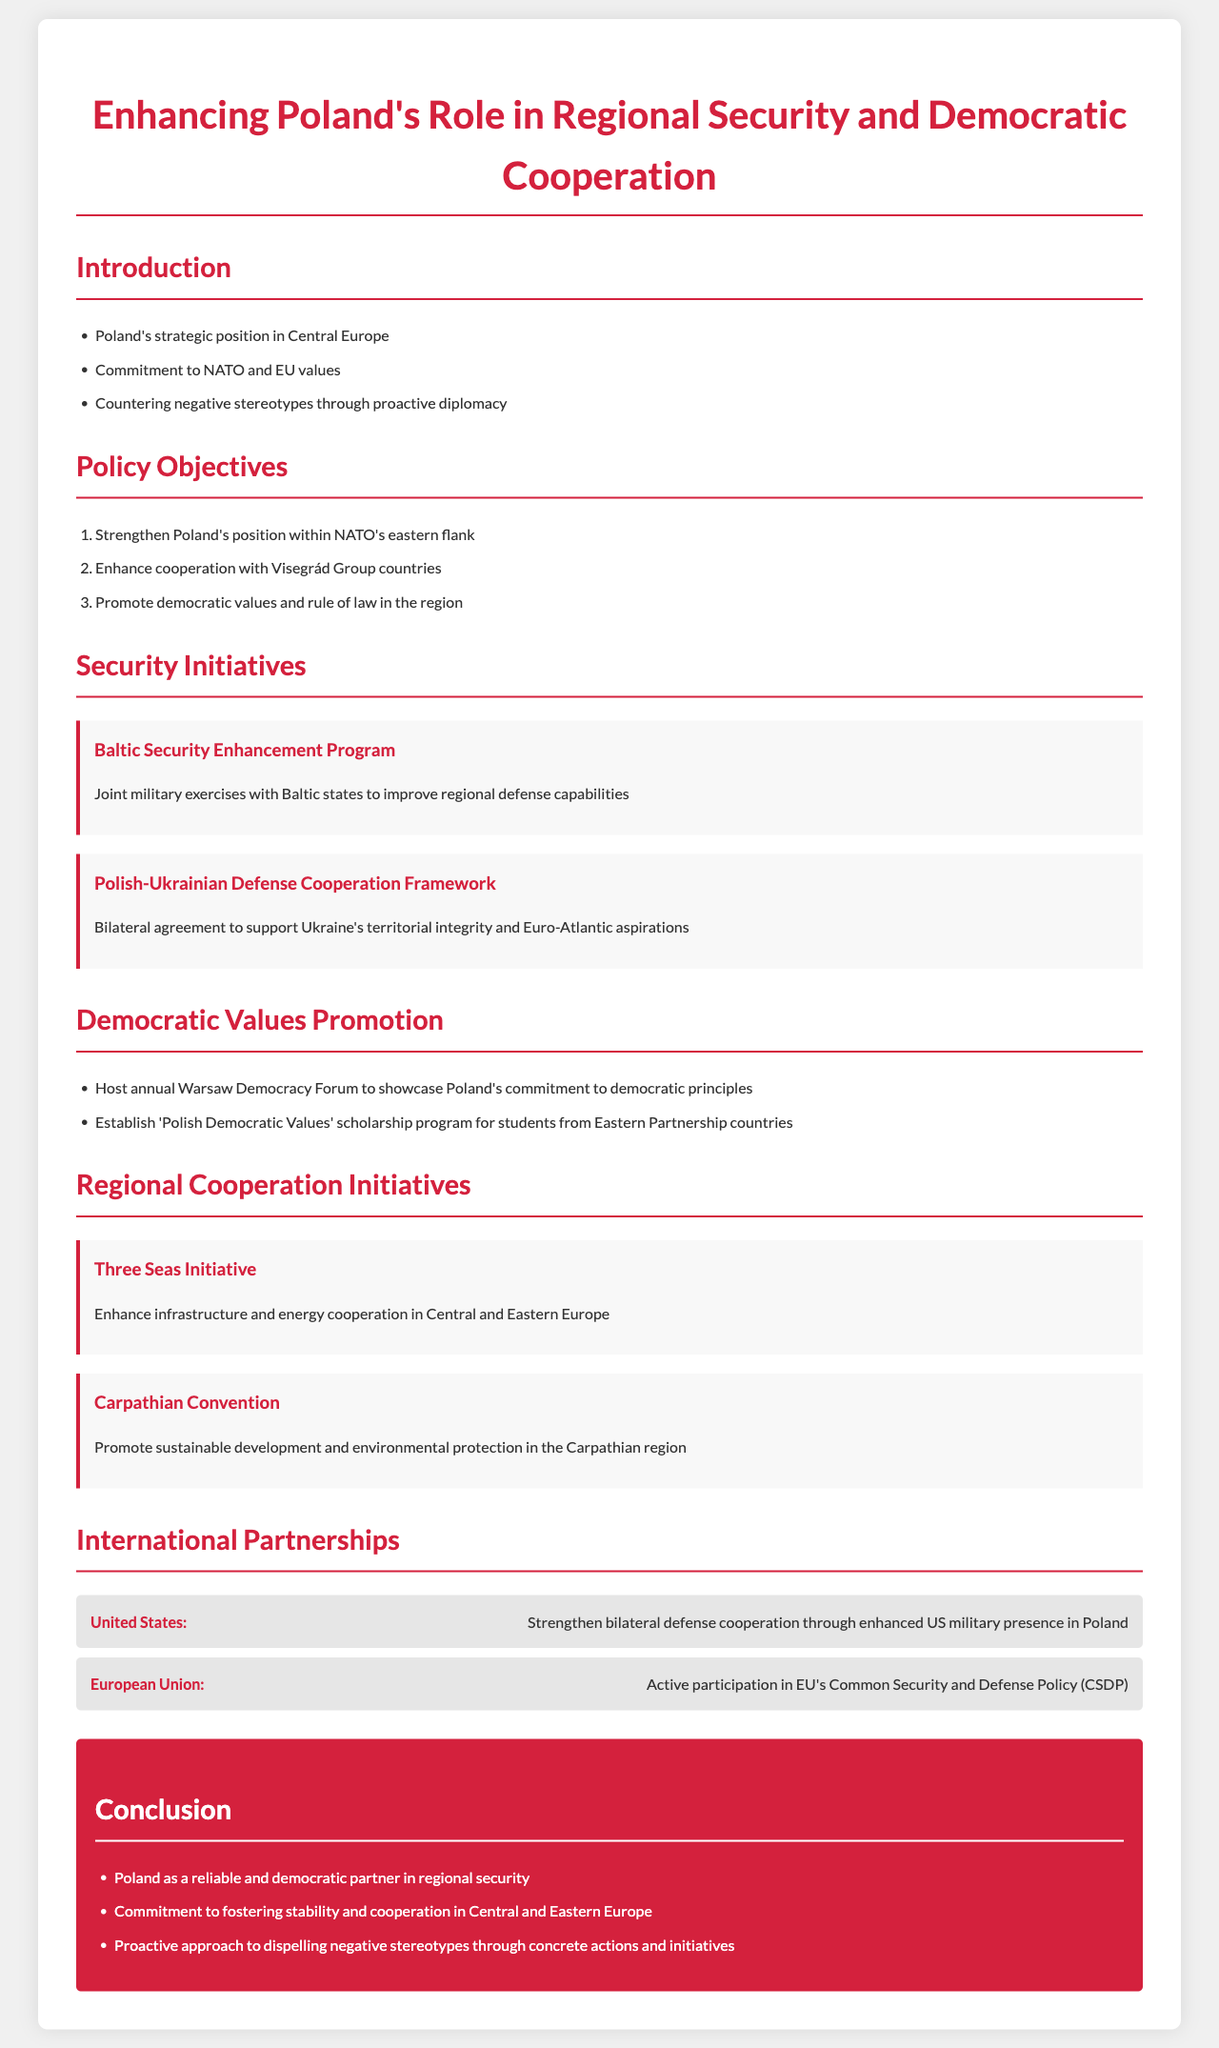What is the title of the document? The title of the document states the focus of the policy framework on regional security and democratic cooperation.
Answer: Enhancing Poland's Role in Regional Security and Democratic Cooperation What does Poland's commitment include? The introduction mentions Poland's commitment to NATO and EU values as a key aspect of its policy framework.
Answer: NATO and EU values What is one policy objective listed in the document? The document outlines several policy objectives, one of which is aimed at strengthening Poland's strategic position.
Answer: Strengthen Poland's position within NATO's eastern flank What is the purpose of the Baltic Security Enhancement Program? The initiative describes joint military exercises aimed at improving defense capabilities in the Baltic region.
Answer: Improve regional defense capabilities In what year is the Warsaw Democracy Forum hosted? The document states that the forum is an annual event to showcase Poland's commitment to democratic principles, indicating a yearly occurrence rather than a specific year.
Answer: Annual What initiative promotes cooperation in Central and Eastern Europe? The document mentions a specific initiative aimed at enhancing infrastructure and energy cooperation among these countries.
Answer: Three Seas Initiative How does Poland intend to counter negative stereotypes? The introduction discusses the proactive diplomatic approach Poland aims to take in order to dispel negative perceptions about the country.
Answer: Proactive diplomacy What is the role of the United States in the partnerships section? The partnership section outlines the strengthening of bilateral defense cooperation as a key aspect of Poland's relationship with the US.
Answer: Strengthen bilateral defense cooperation What does the document conclude about Poland's role? The conclusion emphasizes Poland's reliability as a partner in regional security and its commitment to stability.
Answer: Reliable and democratic partner in regional security 